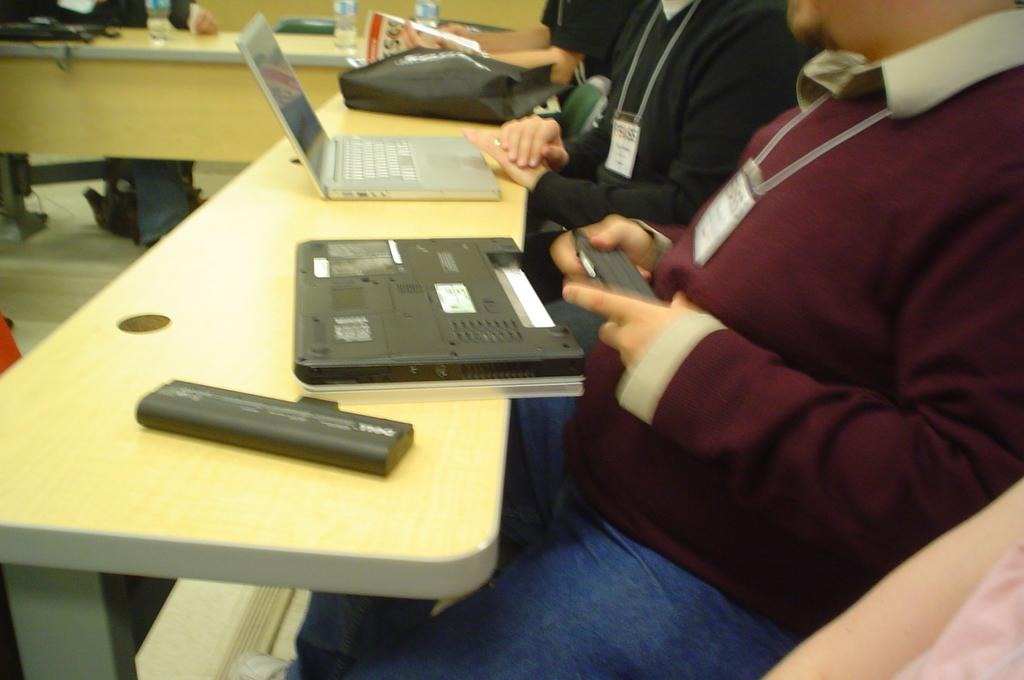How many people are sitting in the image? There are three people sitting on chairs in the image. What can be seen on the table in the image? There is a laptop, a bag, a bottle, and other objects on the table in the image. What might the people be using to work or communicate? The laptop on the table might be used by the people for work or communication. What country is the wrist from in the image? There is no mention of a wrist or a country in the image. 